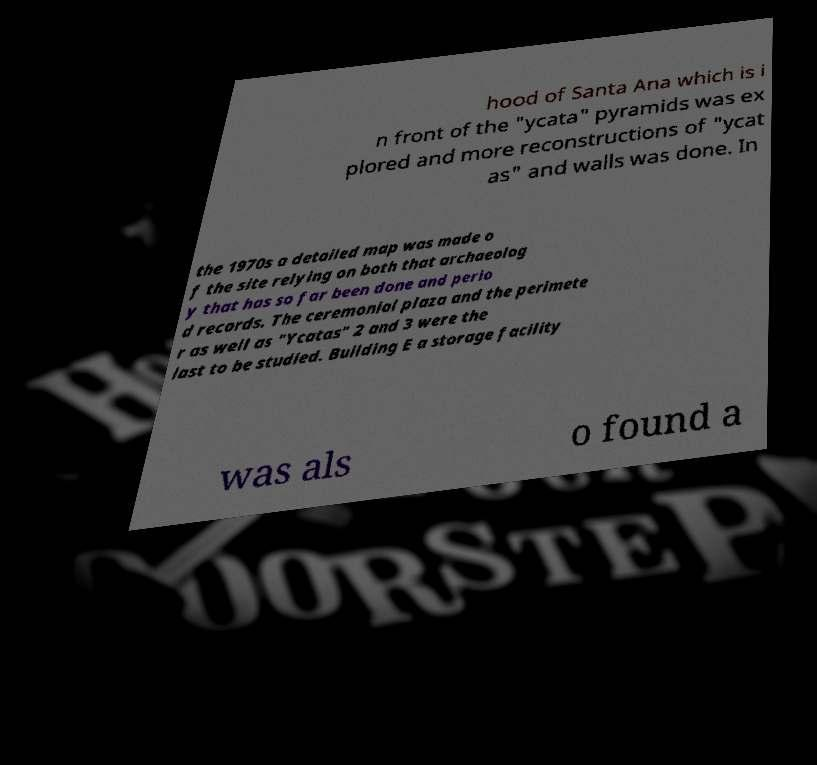There's text embedded in this image that I need extracted. Can you transcribe it verbatim? hood of Santa Ana which is i n front of the "ycata" pyramids was ex plored and more reconstructions of "ycat as" and walls was done. In the 1970s a detailed map was made o f the site relying on both that archaeolog y that has so far been done and perio d records. The ceremonial plaza and the perimete r as well as "Ycatas" 2 and 3 were the last to be studied. Building E a storage facility was als o found a 